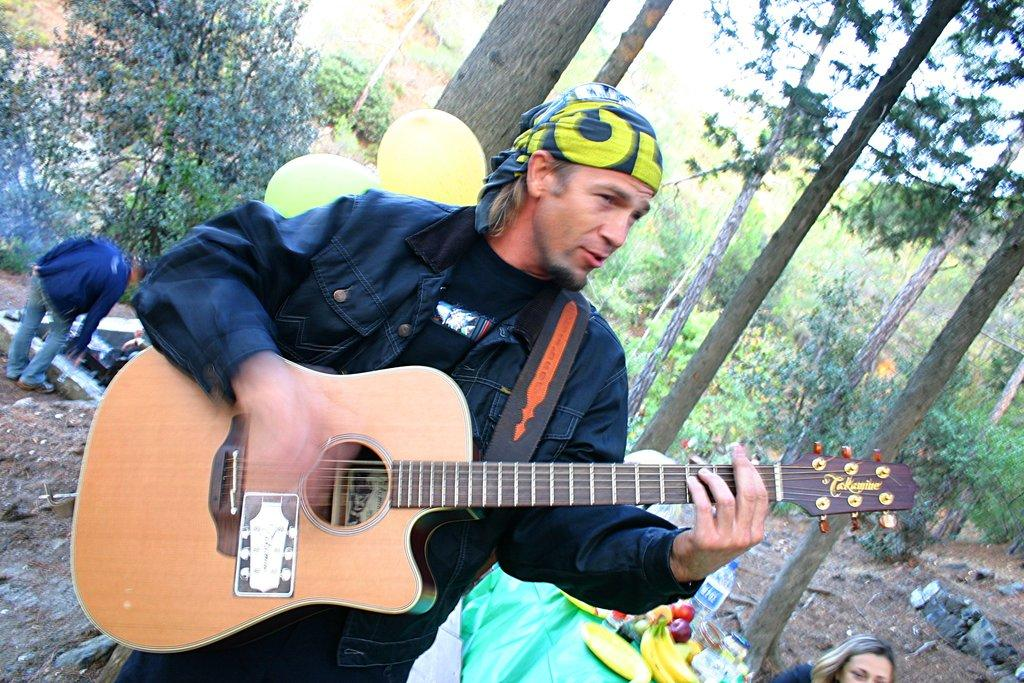How many people are in the image? There are three persons in the image. What is the man in the image doing? The man is playing a guitar in the image. What can be seen in the background of the image? There are trees visible in the background of the image. What is on the table in the image? There is a table with food on it in the image. What type of pet is sitting next to the man playing the guitar? There is no pet visible in the image; only three persons and a guitar can be seen. 